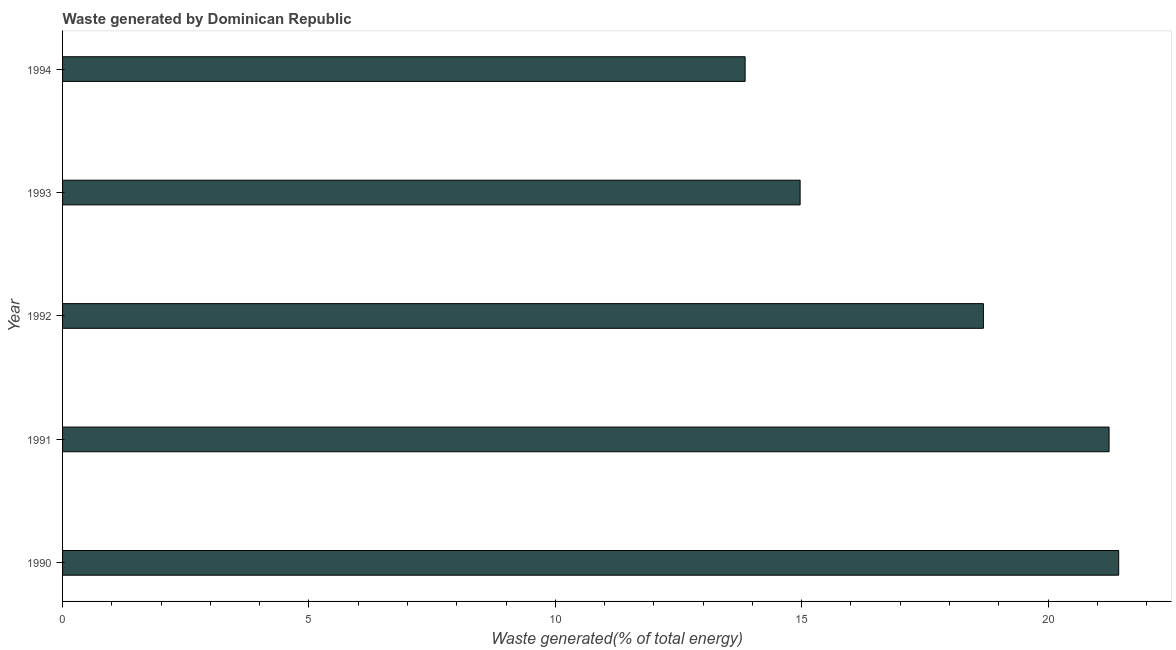What is the title of the graph?
Provide a short and direct response. Waste generated by Dominican Republic. What is the label or title of the X-axis?
Your response must be concise. Waste generated(% of total energy). What is the label or title of the Y-axis?
Your response must be concise. Year. What is the amount of waste generated in 1993?
Your answer should be compact. 14.97. Across all years, what is the maximum amount of waste generated?
Provide a short and direct response. 21.43. Across all years, what is the minimum amount of waste generated?
Your response must be concise. 13.85. In which year was the amount of waste generated minimum?
Your answer should be compact. 1994. What is the sum of the amount of waste generated?
Provide a short and direct response. 90.18. What is the difference between the amount of waste generated in 1993 and 1994?
Ensure brevity in your answer.  1.12. What is the average amount of waste generated per year?
Your answer should be very brief. 18.04. What is the median amount of waste generated?
Provide a short and direct response. 18.69. In how many years, is the amount of waste generated greater than 21 %?
Provide a short and direct response. 2. Do a majority of the years between 1991 and 1993 (inclusive) have amount of waste generated greater than 14 %?
Ensure brevity in your answer.  Yes. What is the ratio of the amount of waste generated in 1993 to that in 1994?
Ensure brevity in your answer.  1.08. Is the amount of waste generated in 1992 less than that in 1994?
Your answer should be very brief. No. What is the difference between the highest and the second highest amount of waste generated?
Your answer should be very brief. 0.2. What is the difference between the highest and the lowest amount of waste generated?
Your answer should be very brief. 7.58. How many bars are there?
Keep it short and to the point. 5. What is the difference between two consecutive major ticks on the X-axis?
Your answer should be very brief. 5. Are the values on the major ticks of X-axis written in scientific E-notation?
Provide a succinct answer. No. What is the Waste generated(% of total energy) of 1990?
Keep it short and to the point. 21.43. What is the Waste generated(% of total energy) of 1991?
Offer a terse response. 21.24. What is the Waste generated(% of total energy) in 1992?
Your response must be concise. 18.69. What is the Waste generated(% of total energy) of 1993?
Ensure brevity in your answer.  14.97. What is the Waste generated(% of total energy) of 1994?
Your answer should be compact. 13.85. What is the difference between the Waste generated(% of total energy) in 1990 and 1991?
Keep it short and to the point. 0.2. What is the difference between the Waste generated(% of total energy) in 1990 and 1992?
Your answer should be very brief. 2.75. What is the difference between the Waste generated(% of total energy) in 1990 and 1993?
Provide a succinct answer. 6.47. What is the difference between the Waste generated(% of total energy) in 1990 and 1994?
Offer a terse response. 7.58. What is the difference between the Waste generated(% of total energy) in 1991 and 1992?
Keep it short and to the point. 2.55. What is the difference between the Waste generated(% of total energy) in 1991 and 1993?
Provide a short and direct response. 6.27. What is the difference between the Waste generated(% of total energy) in 1991 and 1994?
Provide a short and direct response. 7.39. What is the difference between the Waste generated(% of total energy) in 1992 and 1993?
Your answer should be very brief. 3.72. What is the difference between the Waste generated(% of total energy) in 1992 and 1994?
Your answer should be very brief. 4.84. What is the difference between the Waste generated(% of total energy) in 1993 and 1994?
Give a very brief answer. 1.12. What is the ratio of the Waste generated(% of total energy) in 1990 to that in 1992?
Keep it short and to the point. 1.15. What is the ratio of the Waste generated(% of total energy) in 1990 to that in 1993?
Your answer should be very brief. 1.43. What is the ratio of the Waste generated(% of total energy) in 1990 to that in 1994?
Ensure brevity in your answer.  1.55. What is the ratio of the Waste generated(% of total energy) in 1991 to that in 1992?
Your answer should be very brief. 1.14. What is the ratio of the Waste generated(% of total energy) in 1991 to that in 1993?
Make the answer very short. 1.42. What is the ratio of the Waste generated(% of total energy) in 1991 to that in 1994?
Offer a very short reply. 1.53. What is the ratio of the Waste generated(% of total energy) in 1992 to that in 1993?
Keep it short and to the point. 1.25. What is the ratio of the Waste generated(% of total energy) in 1992 to that in 1994?
Keep it short and to the point. 1.35. What is the ratio of the Waste generated(% of total energy) in 1993 to that in 1994?
Provide a succinct answer. 1.08. 